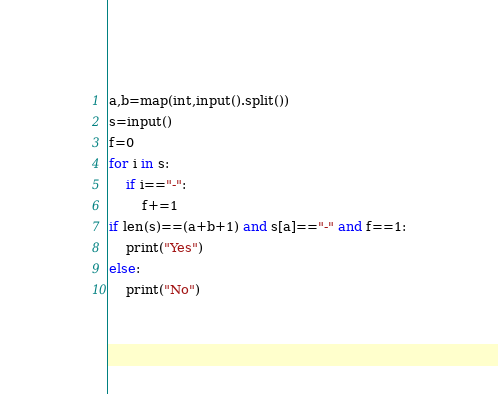<code> <loc_0><loc_0><loc_500><loc_500><_Python_>a,b=map(int,input().split())
s=input()
f=0
for i in s:
    if i=="-":
        f+=1
if len(s)==(a+b+1) and s[a]=="-" and f==1:
    print("Yes")
else:
    print("No")
</code> 